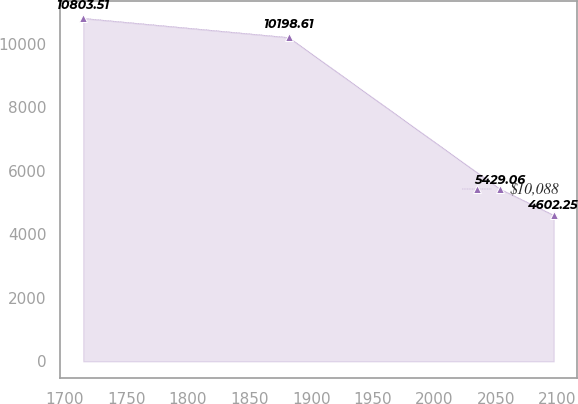Convert chart. <chart><loc_0><loc_0><loc_500><loc_500><line_chart><ecel><fcel>$10,088<nl><fcel>1714.84<fcel>10803.5<nl><fcel>1881.81<fcel>10198.6<nl><fcel>2053.3<fcel>5429.06<nl><fcel>2097<fcel>4602.25<nl></chart> 